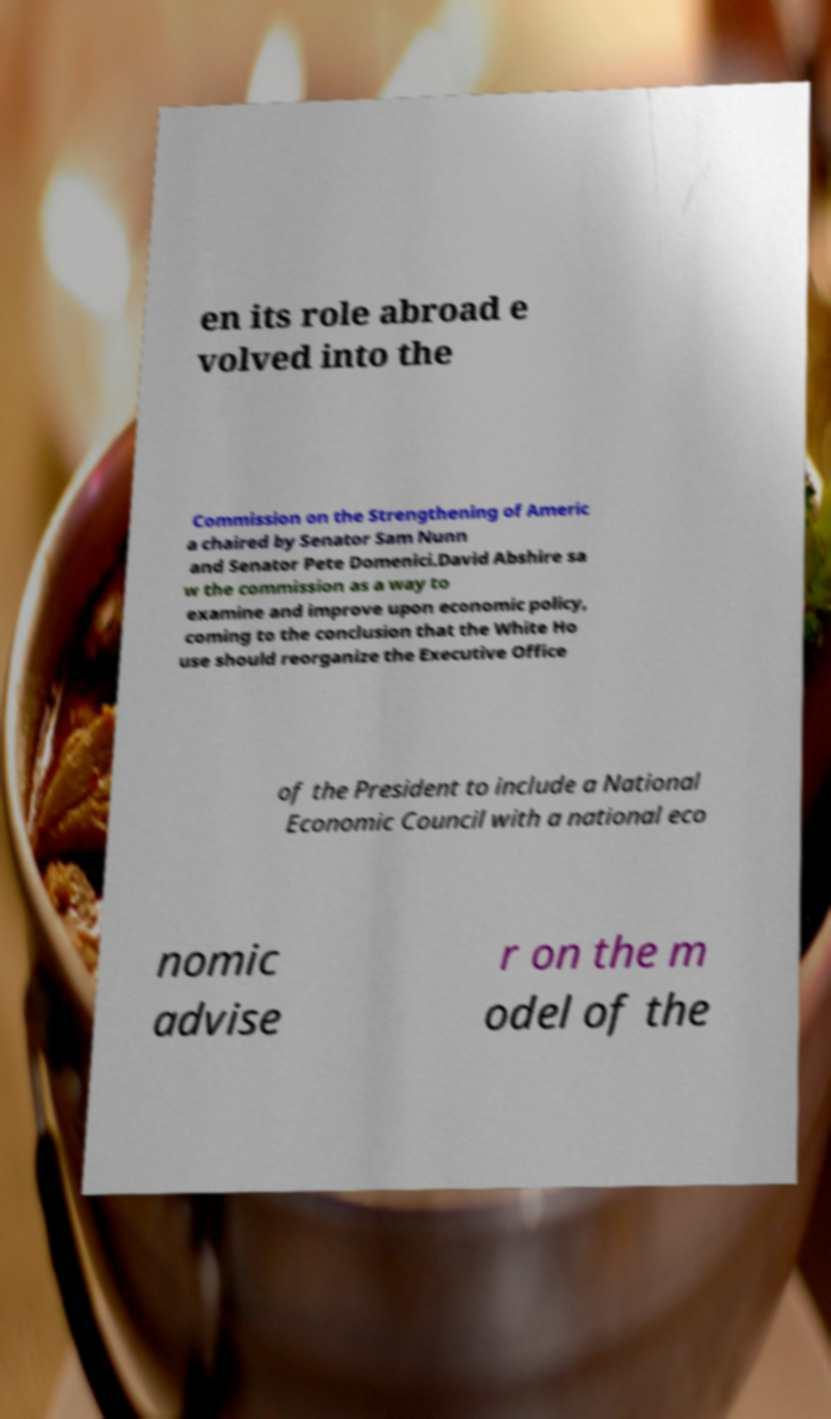There's text embedded in this image that I need extracted. Can you transcribe it verbatim? en its role abroad e volved into the Commission on the Strengthening of Americ a chaired by Senator Sam Nunn and Senator Pete Domenici.David Abshire sa w the commission as a way to examine and improve upon economic policy, coming to the conclusion that the White Ho use should reorganize the Executive Office of the President to include a National Economic Council with a national eco nomic advise r on the m odel of the 